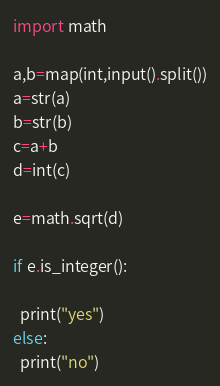Convert code to text. <code><loc_0><loc_0><loc_500><loc_500><_Python_>import math

a,b=map(int,input().split())
a=str(a)
b=str(b)
c=a+b
d=int(c)

e=math.sqrt(d)

if e.is_integer():

  print("yes")
else:
  print("no")</code> 